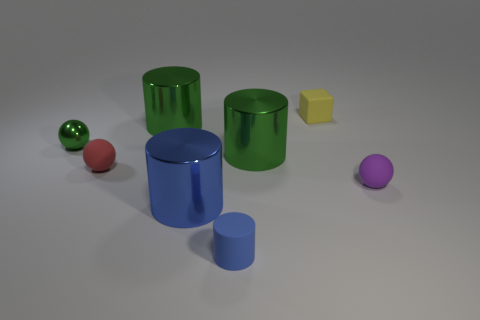Add 1 tiny green metallic objects. How many objects exist? 9 Subtract all spheres. How many objects are left? 5 Subtract 0 blue cubes. How many objects are left? 8 Subtract all tiny green shiny cubes. Subtract all blue things. How many objects are left? 6 Add 2 red matte spheres. How many red matte spheres are left? 3 Add 5 small gray metal balls. How many small gray metal balls exist? 5 